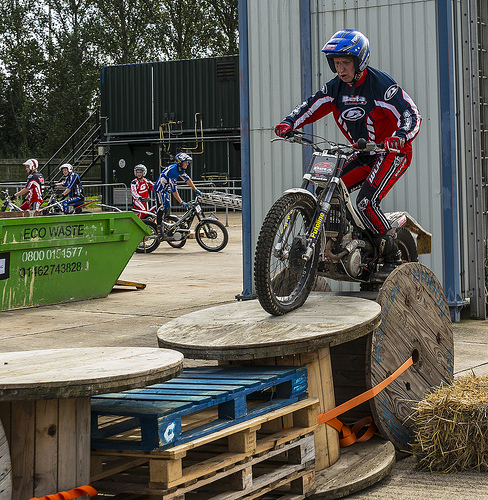<image>
Is there a man above the bike? No. The man is not positioned above the bike. The vertical arrangement shows a different relationship. 